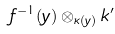Convert formula to latex. <formula><loc_0><loc_0><loc_500><loc_500>f ^ { - 1 } ( y ) \otimes _ { \kappa ( y ) } k ^ { \prime }</formula> 